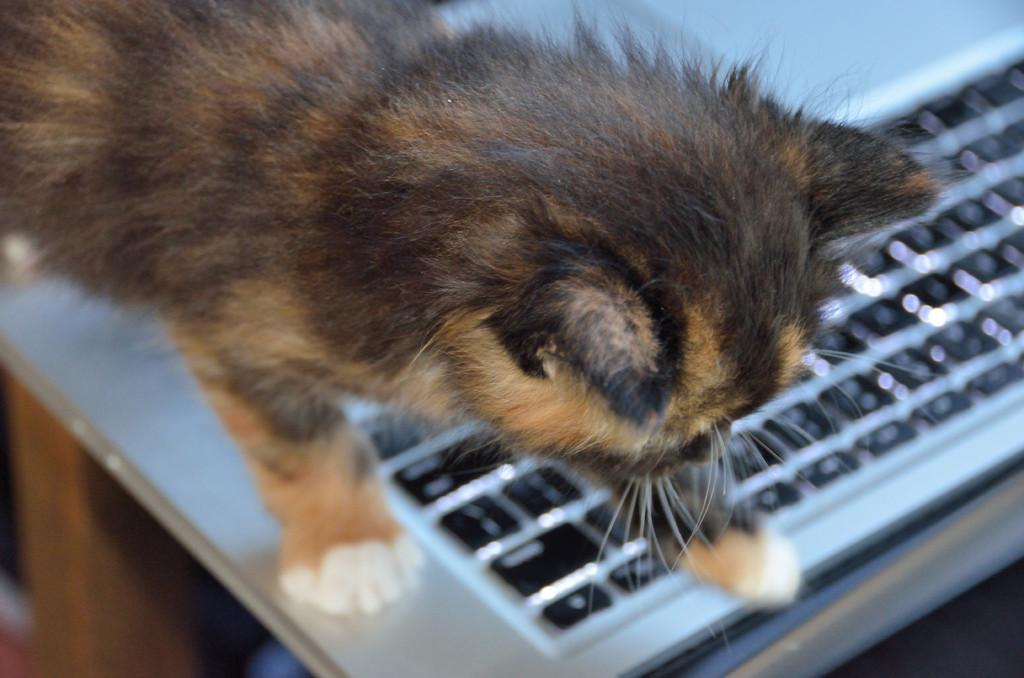What type of animal is in the image? There is a cat in the image. Can you describe the color of the cat? The cat has a cream and black color. What object can be seen in the background of the image? There is a keyboard in the background of the image. How would you describe the clarity of the image? The image is slightly blurry. What type of fish is being offered to the cat in the image? There is no fish or offer present in the image; it only features a cat and a keyboard in the background. 